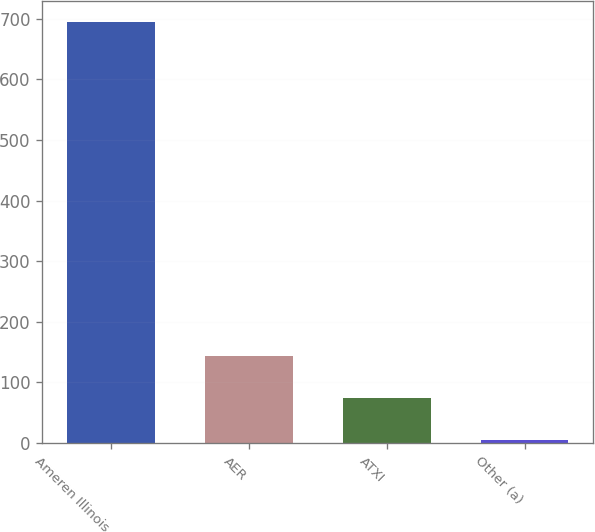Convert chart to OTSL. <chart><loc_0><loc_0><loc_500><loc_500><bar_chart><fcel>Ameren Illinois<fcel>AER<fcel>ATXI<fcel>Other (a)<nl><fcel>695<fcel>143<fcel>74<fcel>5<nl></chart> 